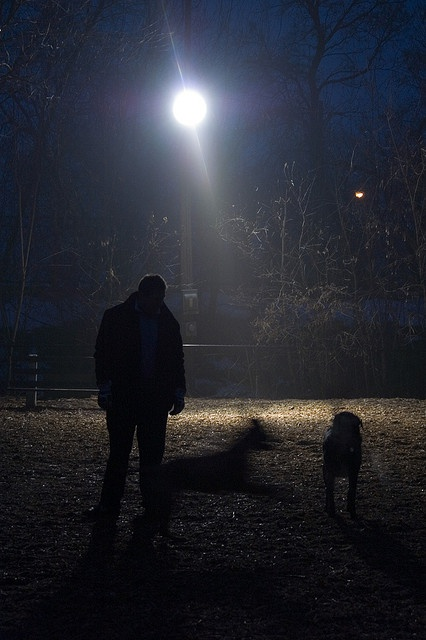Describe the objects in this image and their specific colors. I can see people in black and gray tones, dog in black and gray tones, and dog in black and gray tones in this image. 